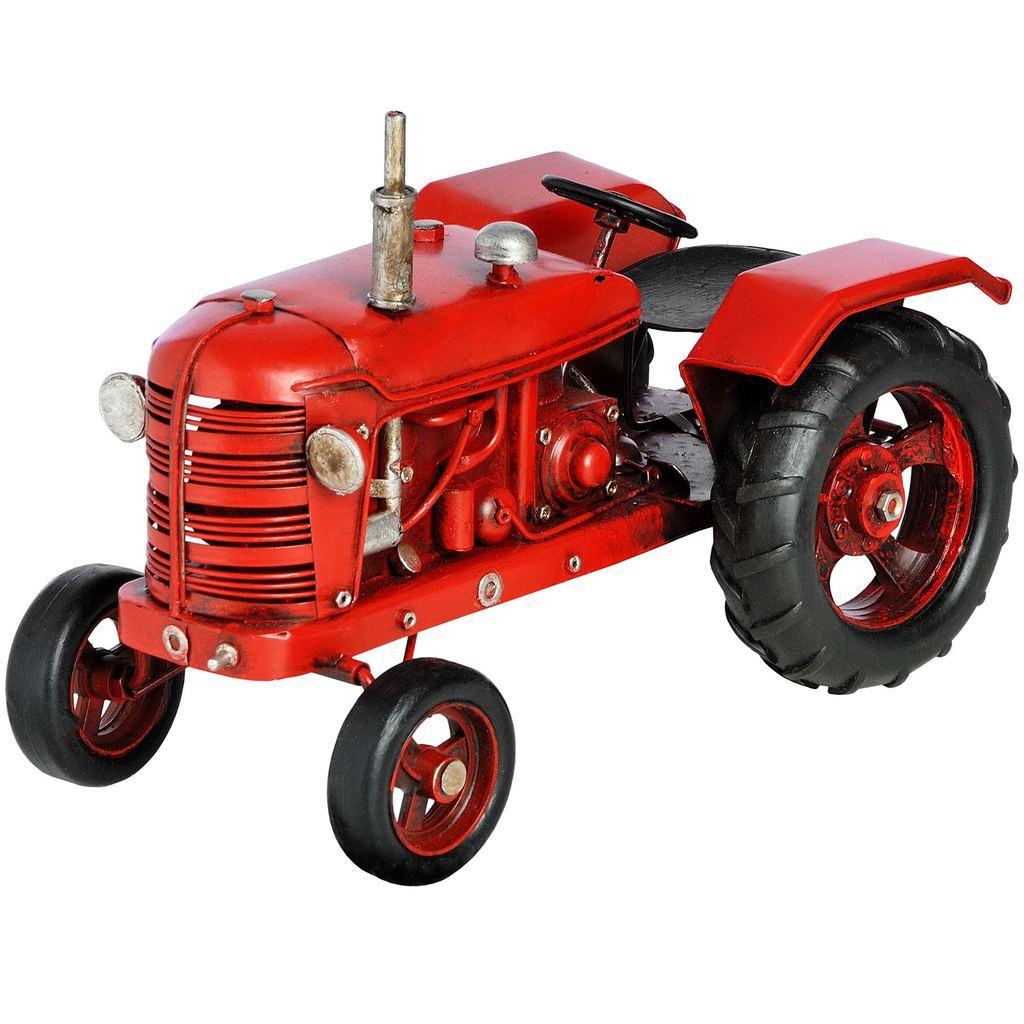Could you give a brief overview of what you see in this image? In this image we can see a red colored tractor and the background is white in color. 